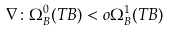Convert formula to latex. <formula><loc_0><loc_0><loc_500><loc_500>\nabla \colon \Omega ^ { 0 } _ { B } ( T B ) < o \Omega ^ { 1 } _ { B } ( T B )</formula> 